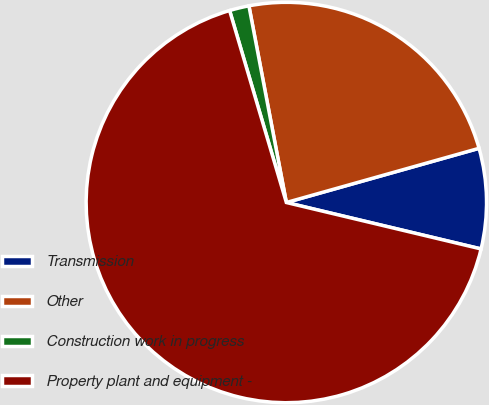Convert chart. <chart><loc_0><loc_0><loc_500><loc_500><pie_chart><fcel>Transmission<fcel>Other<fcel>Construction work in progress<fcel>Property plant and equipment -<nl><fcel>8.09%<fcel>23.63%<fcel>1.58%<fcel>66.7%<nl></chart> 